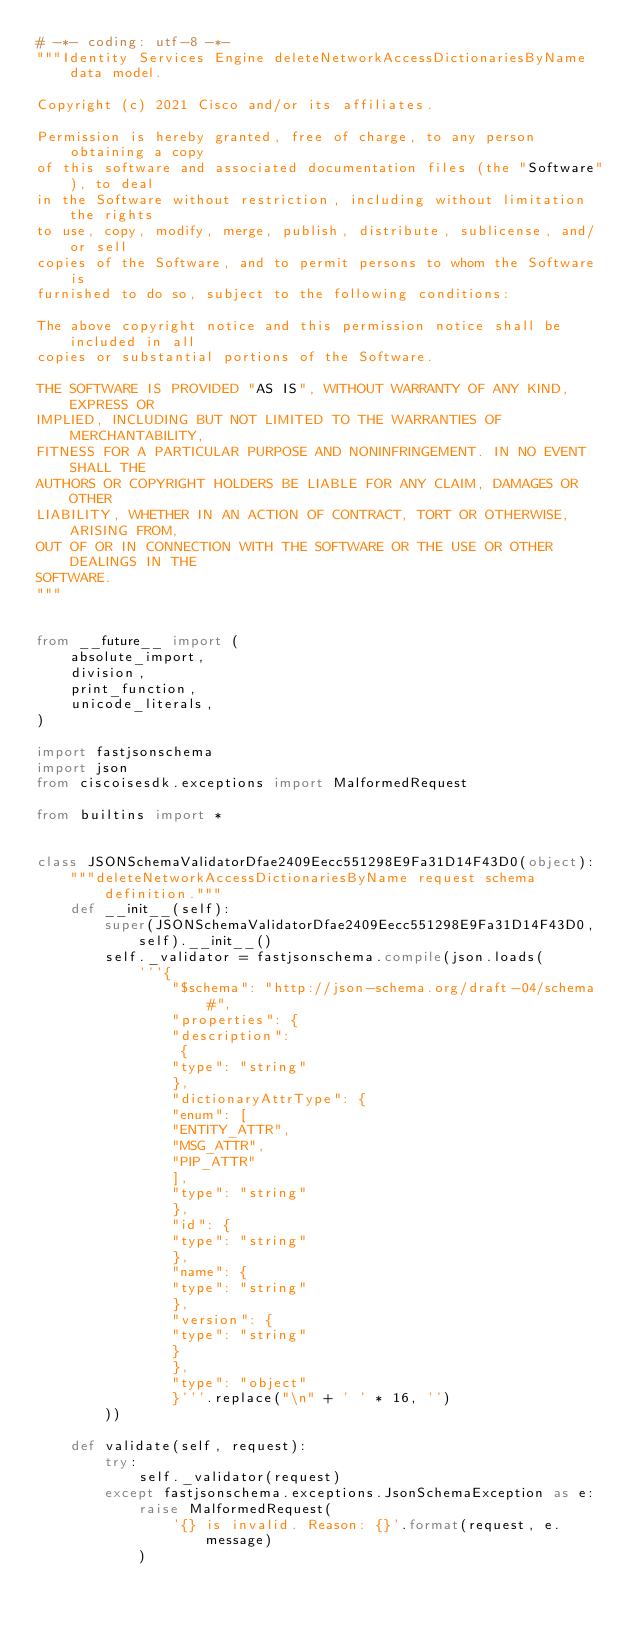<code> <loc_0><loc_0><loc_500><loc_500><_Python_># -*- coding: utf-8 -*-
"""Identity Services Engine deleteNetworkAccessDictionariesByName data model.

Copyright (c) 2021 Cisco and/or its affiliates.

Permission is hereby granted, free of charge, to any person obtaining a copy
of this software and associated documentation files (the "Software"), to deal
in the Software without restriction, including without limitation the rights
to use, copy, modify, merge, publish, distribute, sublicense, and/or sell
copies of the Software, and to permit persons to whom the Software is
furnished to do so, subject to the following conditions:

The above copyright notice and this permission notice shall be included in all
copies or substantial portions of the Software.

THE SOFTWARE IS PROVIDED "AS IS", WITHOUT WARRANTY OF ANY KIND, EXPRESS OR
IMPLIED, INCLUDING BUT NOT LIMITED TO THE WARRANTIES OF MERCHANTABILITY,
FITNESS FOR A PARTICULAR PURPOSE AND NONINFRINGEMENT. IN NO EVENT SHALL THE
AUTHORS OR COPYRIGHT HOLDERS BE LIABLE FOR ANY CLAIM, DAMAGES OR OTHER
LIABILITY, WHETHER IN AN ACTION OF CONTRACT, TORT OR OTHERWISE, ARISING FROM,
OUT OF OR IN CONNECTION WITH THE SOFTWARE OR THE USE OR OTHER DEALINGS IN THE
SOFTWARE.
"""


from __future__ import (
    absolute_import,
    division,
    print_function,
    unicode_literals,
)

import fastjsonschema
import json
from ciscoisesdk.exceptions import MalformedRequest

from builtins import *


class JSONSchemaValidatorDfae2409Eecc551298E9Fa31D14F43D0(object):
    """deleteNetworkAccessDictionariesByName request schema definition."""
    def __init__(self):
        super(JSONSchemaValidatorDfae2409Eecc551298E9Fa31D14F43D0, self).__init__()
        self._validator = fastjsonschema.compile(json.loads(
            '''{
                "$schema": "http://json-schema.org/draft-04/schema#",
                "properties": {
                "description":
                 {
                "type": "string"
                },
                "dictionaryAttrType": {
                "enum": [
                "ENTITY_ATTR",
                "MSG_ATTR",
                "PIP_ATTR"
                ],
                "type": "string"
                },
                "id": {
                "type": "string"
                },
                "name": {
                "type": "string"
                },
                "version": {
                "type": "string"
                }
                },
                "type": "object"
                }'''.replace("\n" + ' ' * 16, '')
        ))

    def validate(self, request):
        try:
            self._validator(request)
        except fastjsonschema.exceptions.JsonSchemaException as e:
            raise MalformedRequest(
                '{} is invalid. Reason: {}'.format(request, e.message)
            )
</code> 